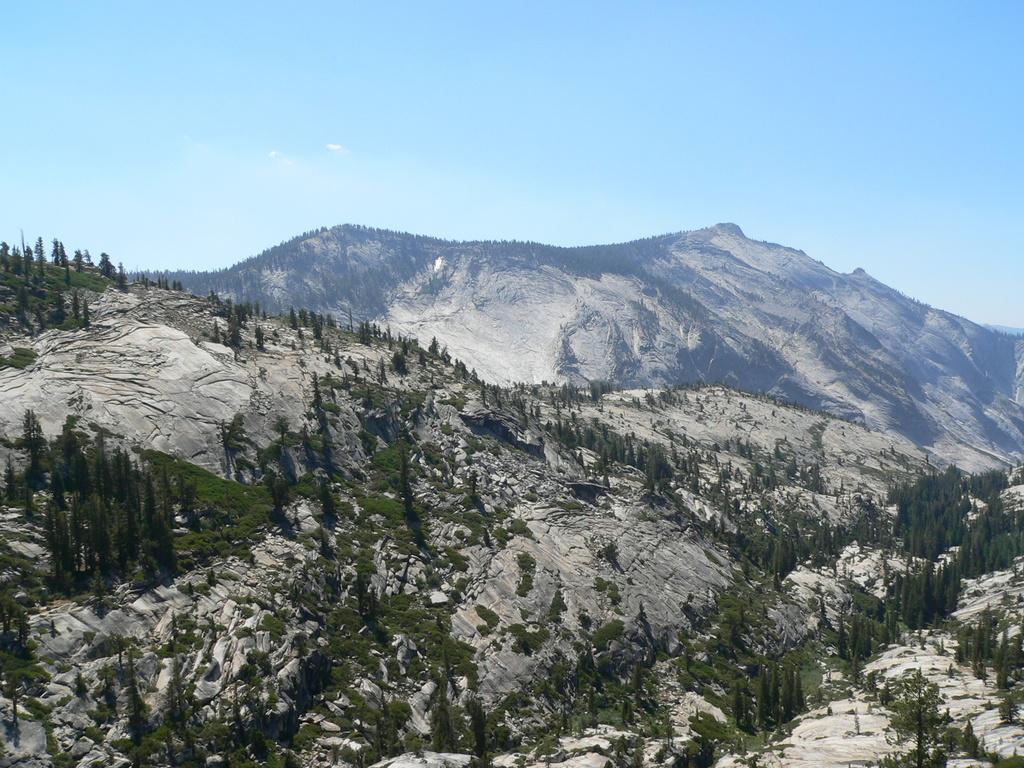How would you summarize this image in a sentence or two? At the bottom, we see the hills and the trees. There are trees and the hills in the background. At the top, we see the sky. 